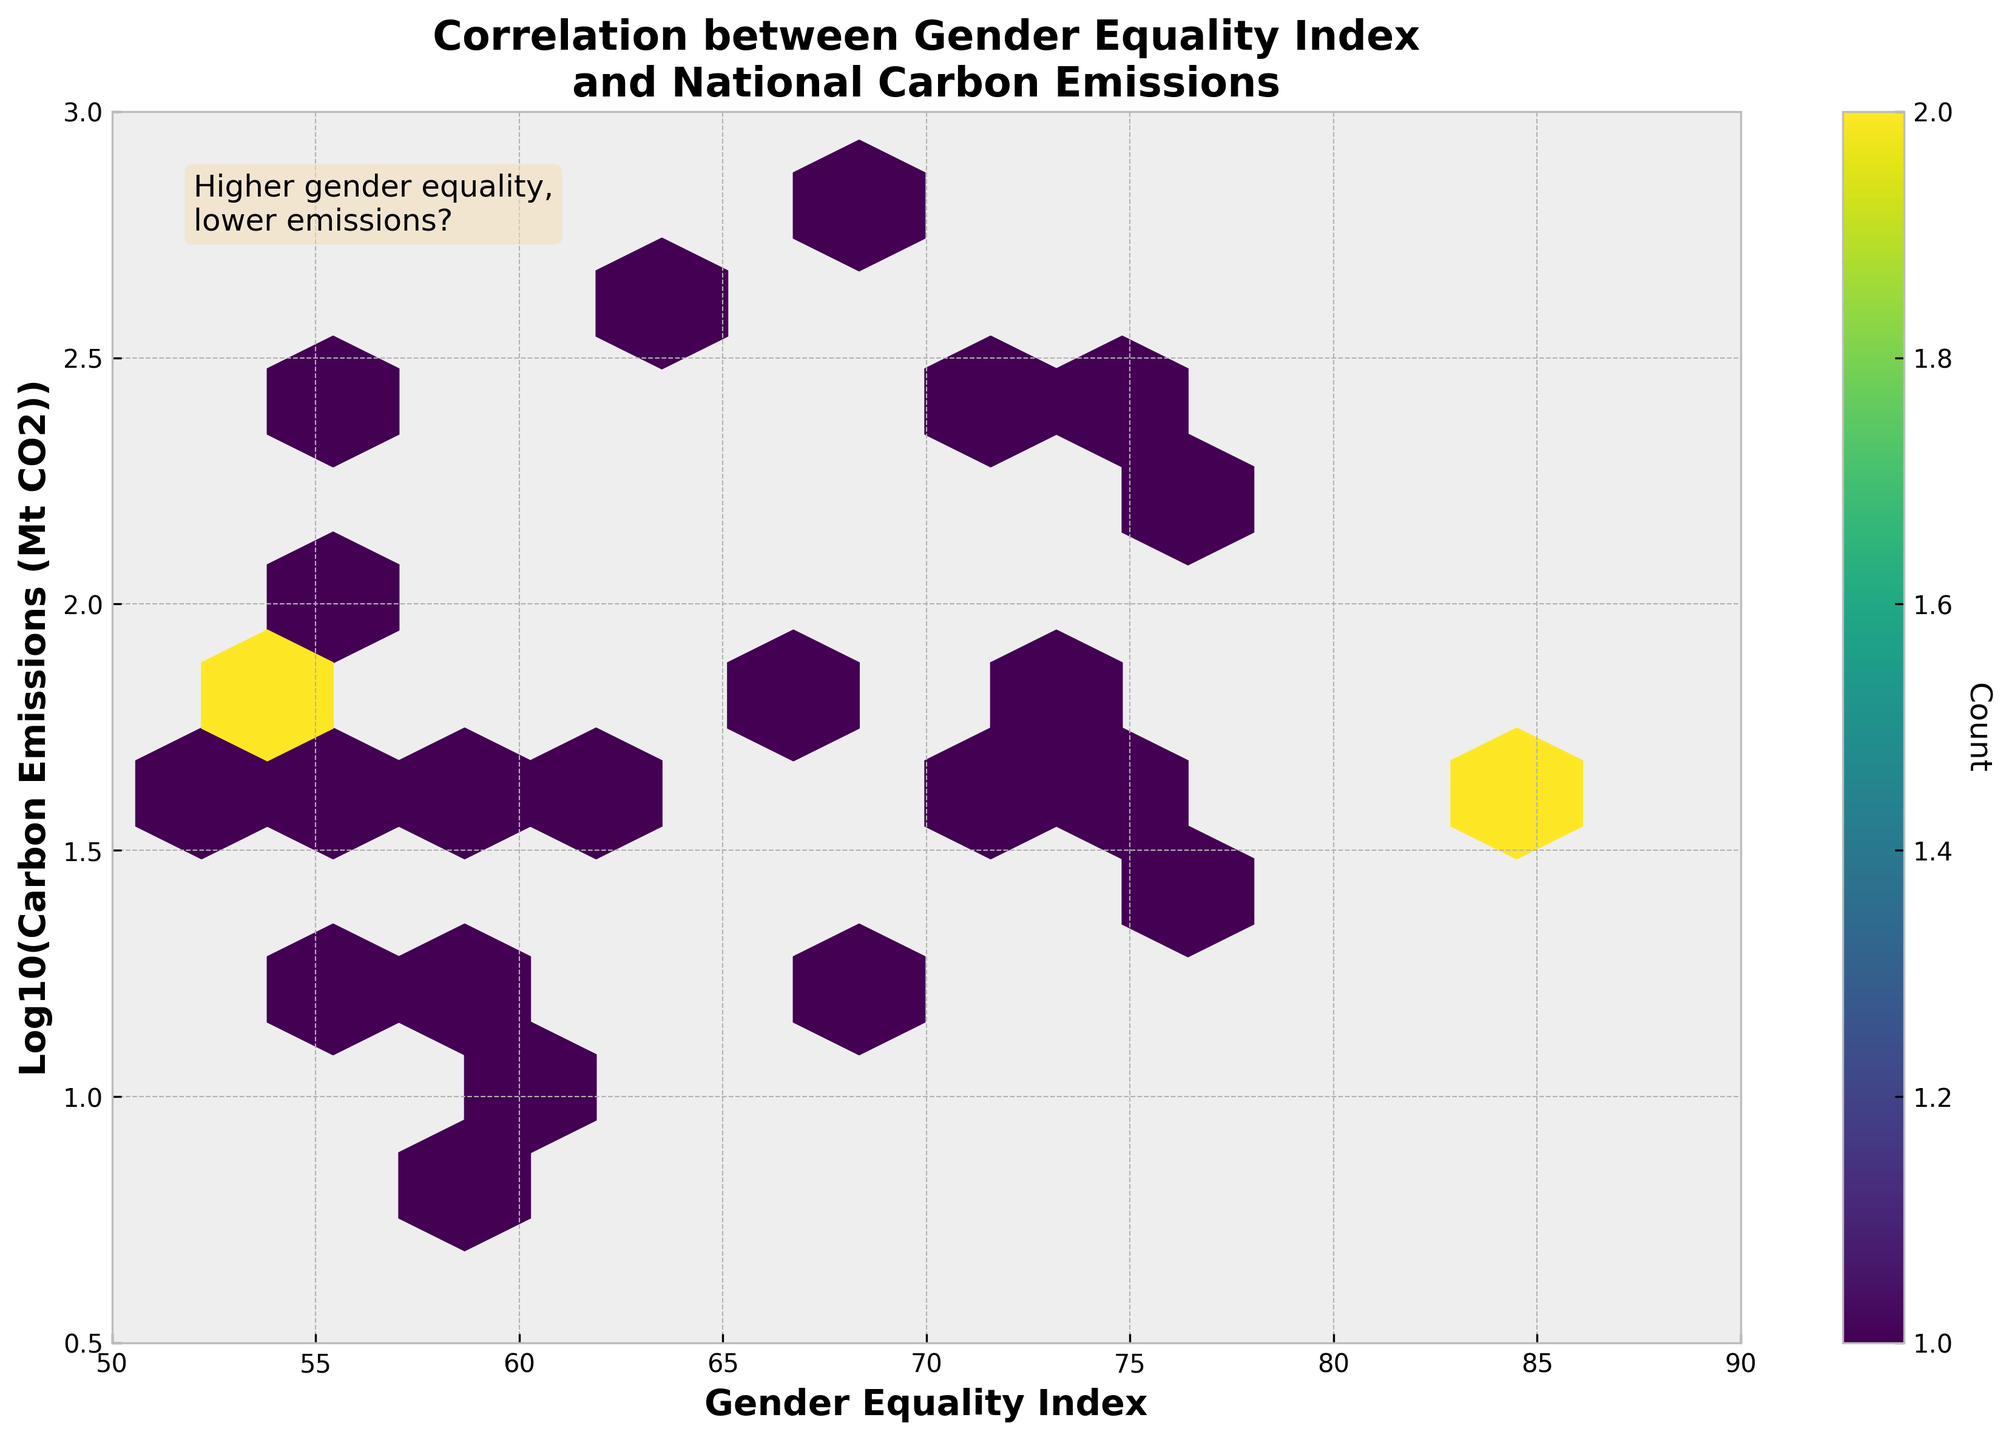How many bins contain data points? The colorbar indicates that bins with data points range from 1 to the maximum color intensity shown. You need to identify all hexagonal bins that are filled with color as they represent data points.
Answer: 10 What is the title of the figure? The title of the figure is displayed prominently at the top of the plot.
Answer: Correlation between Gender Equality Index and National Carbon Emissions What is the range of the Gender Equality Index on the x-axis? The x-axis at the bottom of the plot shows the range of the Gender Equality Index.
Answer: 50 to 90 What does the color intensity in the hexbin plot represent? The color intensity of the hexagons represents the count of data points within each bin, as described by the colorbar.
Answer: Count of data points Is there a visible trend between the Gender Equality Index and Carbon Emissions? The trend can be observed by noting the distribution and direction of the points. The plot shows that as the Gender Equality Index increases, there is a tendency for lower carbon emissions.
Answer: Yes, there is a visible trend showing higher gender equality tends to correlate with lower emissions What is the transformed scale used for Carbon Emissions on the y-axis? The label on the y-axis mentions the transformation applied to the Carbon Emissions.
Answer: Log10 scale Which country likely has the highest carbon emissions based on the log scale? By examining the range and the placement of hexagons, the country with the highest carbon emissions will be at the top of the y-axis.
Answer: Germany What hexagonal grid color is used for the highest bin count? The color corresponding to the highest bin count can be identified by looking at the darker shades in the hexbin plot.
Answer: Darkest shade of viridis What value is roughly the central tendency for the Gender Equality Index data points in the plot? By looking for clusters and the central dense region in the plot on the x-axis, one can estimate the central value.
Answer: Around 70 to 75 Does the figure suggest any outliers in terms of high emissions with high gender equality? Analyzing the higher range on the y-axis (log scale of emissions) while also scanning for high values on the x-axis (Gender Equality Index) can highlight any outliers.
Answer: No distinct outliers Based on the plot, does higher gender equality assure low carbon emissions? Despite the trend, looking at the dispersion of points in the hexbin plot, you can observe whether the relationship is absolute or not.
Answer: No, it suggests a trend but does not assure it 